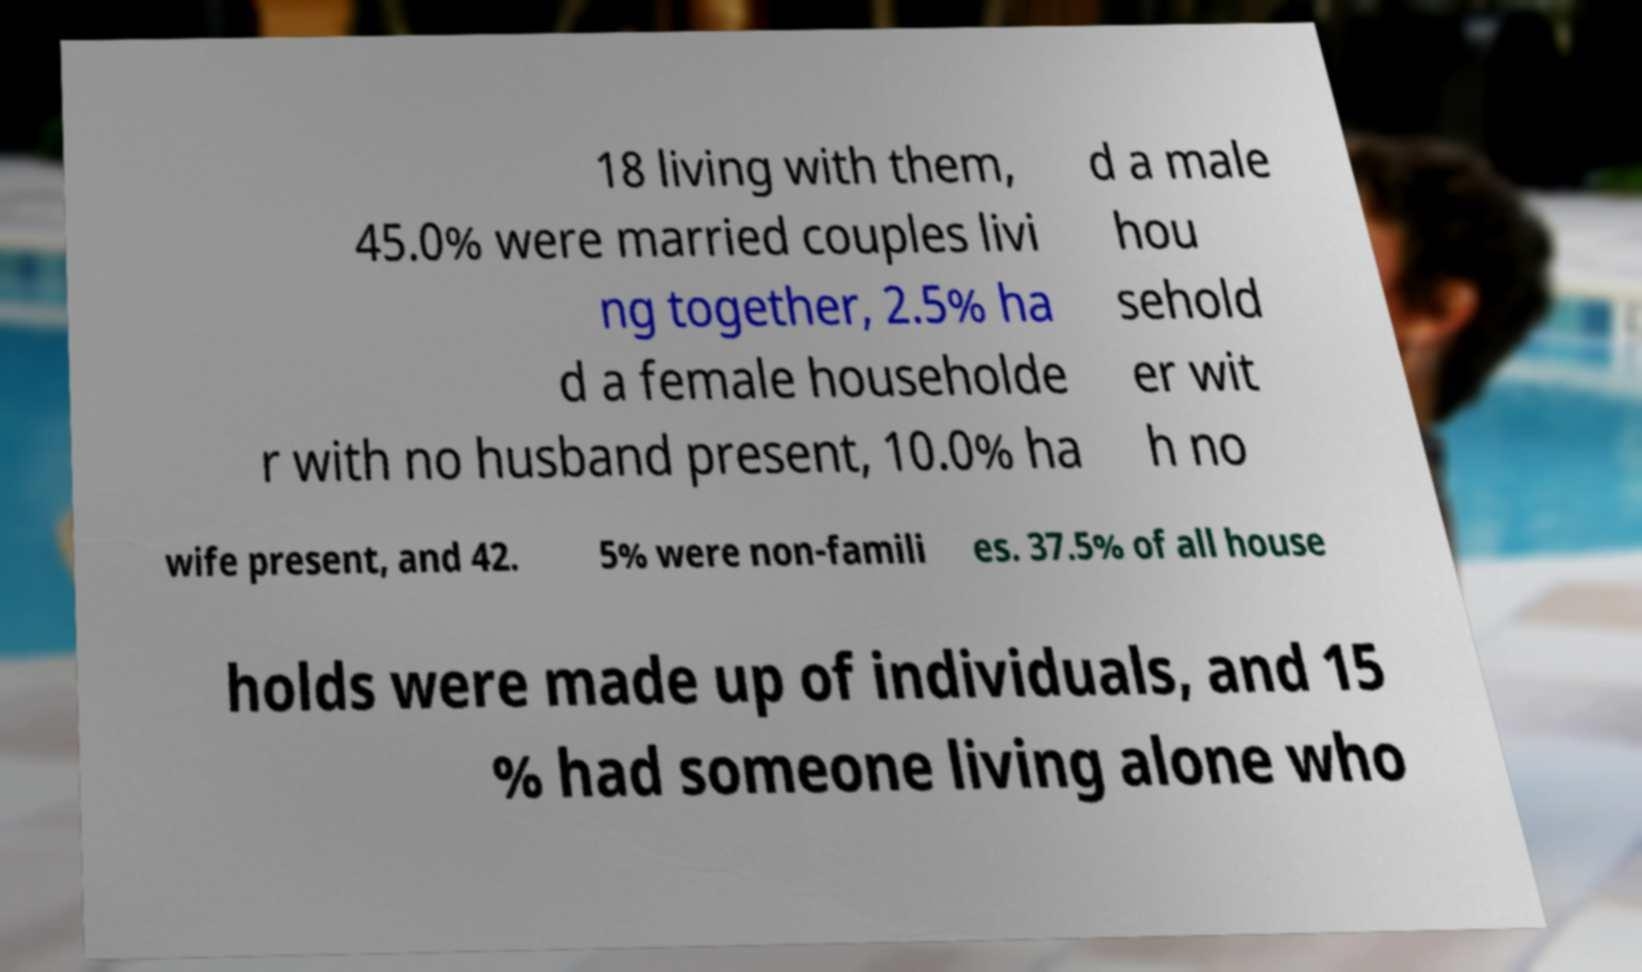Could you extract and type out the text from this image? 18 living with them, 45.0% were married couples livi ng together, 2.5% ha d a female householde r with no husband present, 10.0% ha d a male hou sehold er wit h no wife present, and 42. 5% were non-famili es. 37.5% of all house holds were made up of individuals, and 15 % had someone living alone who 